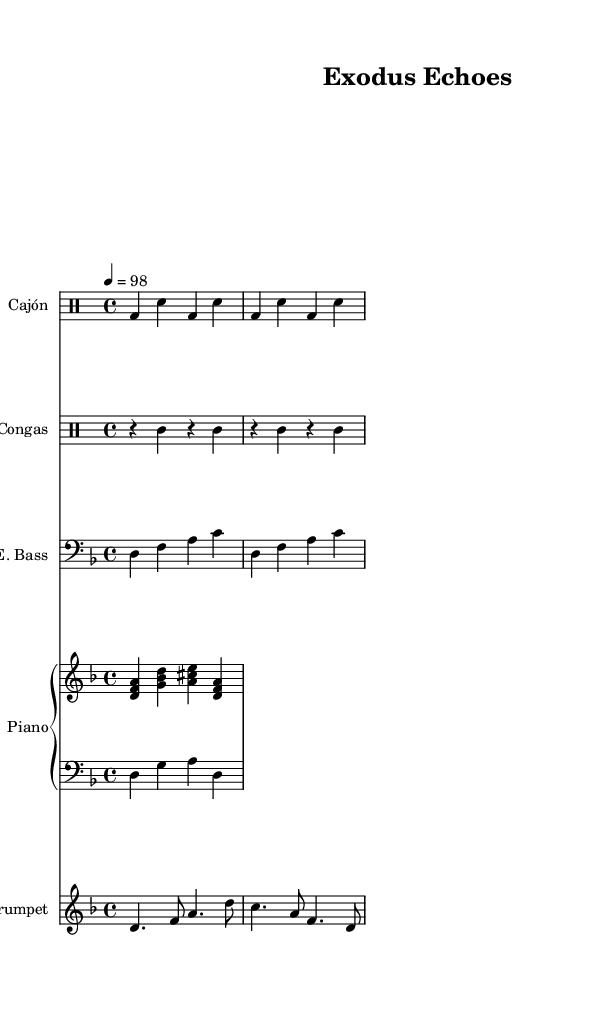What is the key signature of this music? The key signature is indicated by the number of sharps or flats at the beginning of the piece. Here it shows one flat, which corresponds to D minor.
Answer: D minor What is the time signature of this music? The time signature tells us the number of beats in each measure. Here, it is shown as 4/4, meaning there are four beats per measure.
Answer: 4/4 What is the tempo marking of the piece? The tempo marking, written as "4 = 98," indicates the number of quarter notes per minute. It specifies the speed at which the piece should be played.
Answer: 98 How many different percussion instruments are used in this piece? The score lists distinct sections for Cajón and Congas, indicating there are two percussion instruments being utilized.
Answer: 2 Which instrument plays the lowest notes in the score? The lowest notes can typically be found in the bass clef. Here, the electric bass part is written in the bass clef and plays the lowest range of pitches.
Answer: Electric Bass What is the rhythmic pattern used in the Cajón part? To determine the rhythmic pattern, we analyze the structure of the Cajón part, which consistently alternates between bass drum and snare hits in a repeating pattern. The notation suggests a fairly consistent rhythm often found in Afro-Latin music.
Answer: Bass and snare What is the primary genre to which this music belongs? By analyzing the instrumentation and the rhythmic patterns, we can identify this piece as a fusion of Afro-Latin rhythms, often characterized by complex percussion alongside melodic elements.
Answer: Afro-Latin fusion 